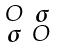Convert formula to latex. <formula><loc_0><loc_0><loc_500><loc_500>\begin{smallmatrix} O & { \boldsymbol \sigma } \\ { \boldsymbol \sigma } & O \end{smallmatrix}</formula> 